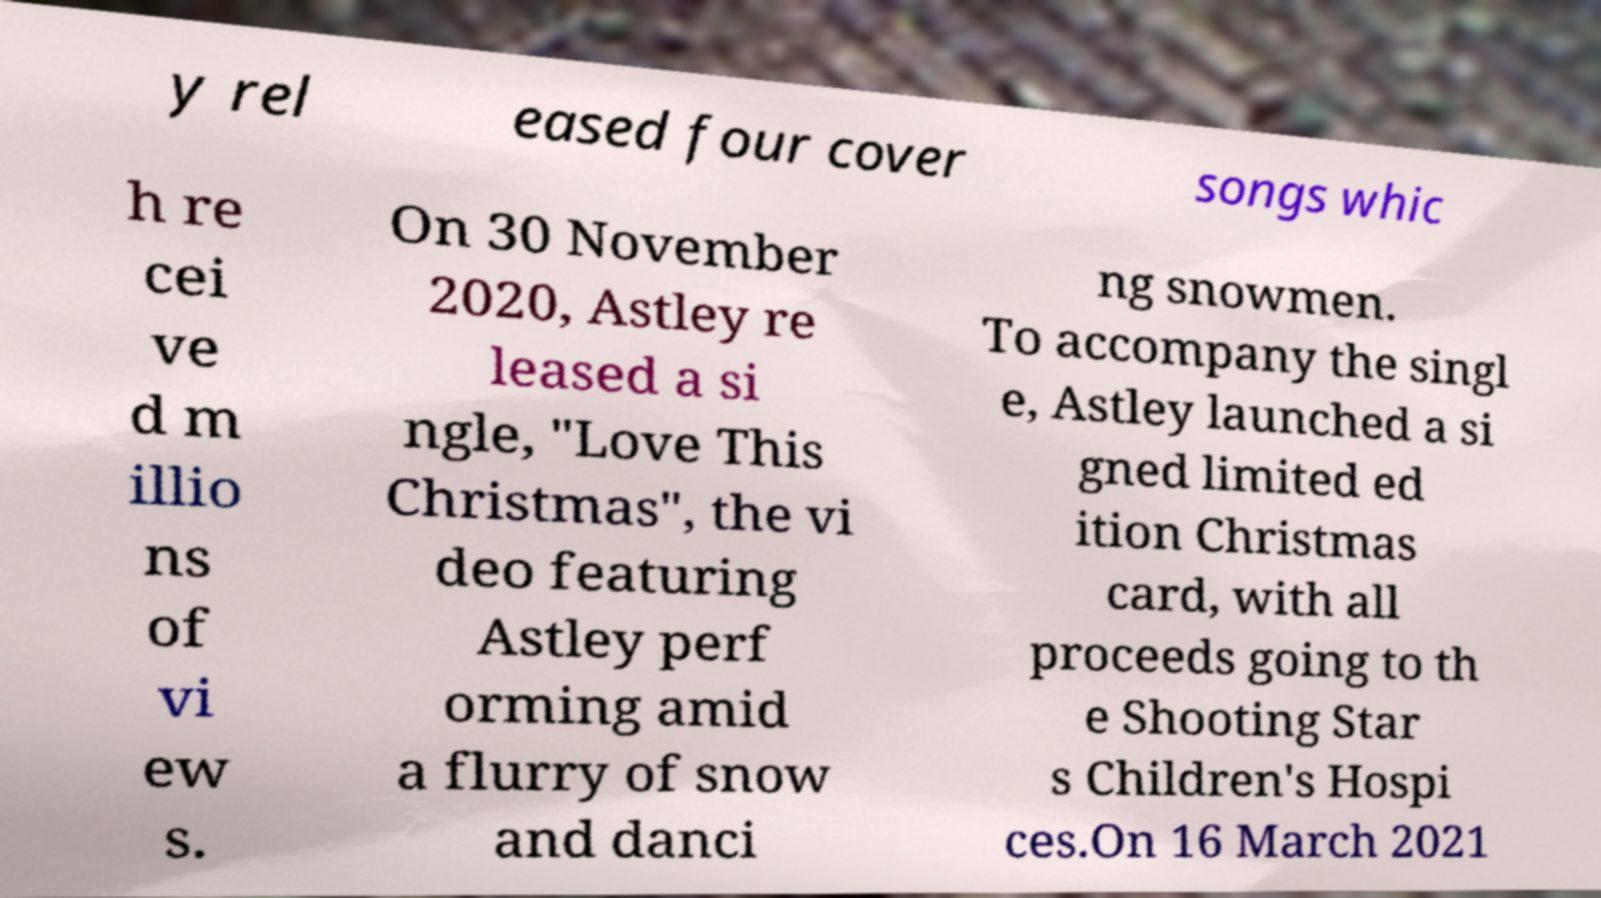I need the written content from this picture converted into text. Can you do that? y rel eased four cover songs whic h re cei ve d m illio ns of vi ew s. On 30 November 2020, Astley re leased a si ngle, "Love This Christmas", the vi deo featuring Astley perf orming amid a flurry of snow and danci ng snowmen. To accompany the singl e, Astley launched a si gned limited ed ition Christmas card, with all proceeds going to th e Shooting Star s Children's Hospi ces.On 16 March 2021 